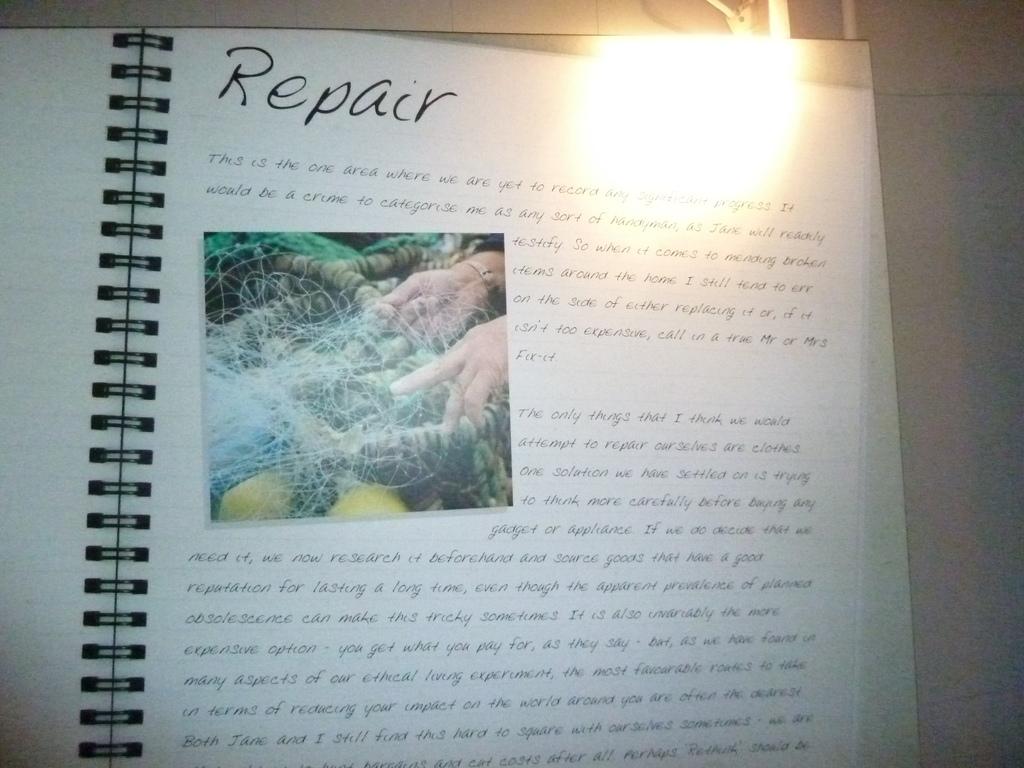What is the title of this page?
Give a very brief answer. Repair. What language is the page written in?
Provide a succinct answer. English. 